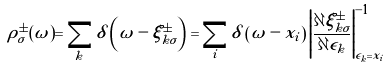<formula> <loc_0><loc_0><loc_500><loc_500>\rho _ { \sigma } ^ { \pm } ( \omega ) = \sum _ { k } \delta \left ( \omega - \xi _ { k \sigma } ^ { \pm } \right ) = \sum _ { i } \delta \left ( \omega - x _ { i } \right ) \left | \frac { \partial \xi _ { k \sigma } ^ { \pm } } { \partial \epsilon _ { k } } \right | _ { \epsilon _ { k } = x _ { i } } ^ { - 1 }</formula> 